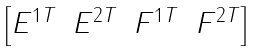Convert formula to latex. <formula><loc_0><loc_0><loc_500><loc_500>\begin{bmatrix} E ^ { 1 T } & E ^ { 2 T } & F ^ { 1 T } & F ^ { 2 T } \end{bmatrix}</formula> 